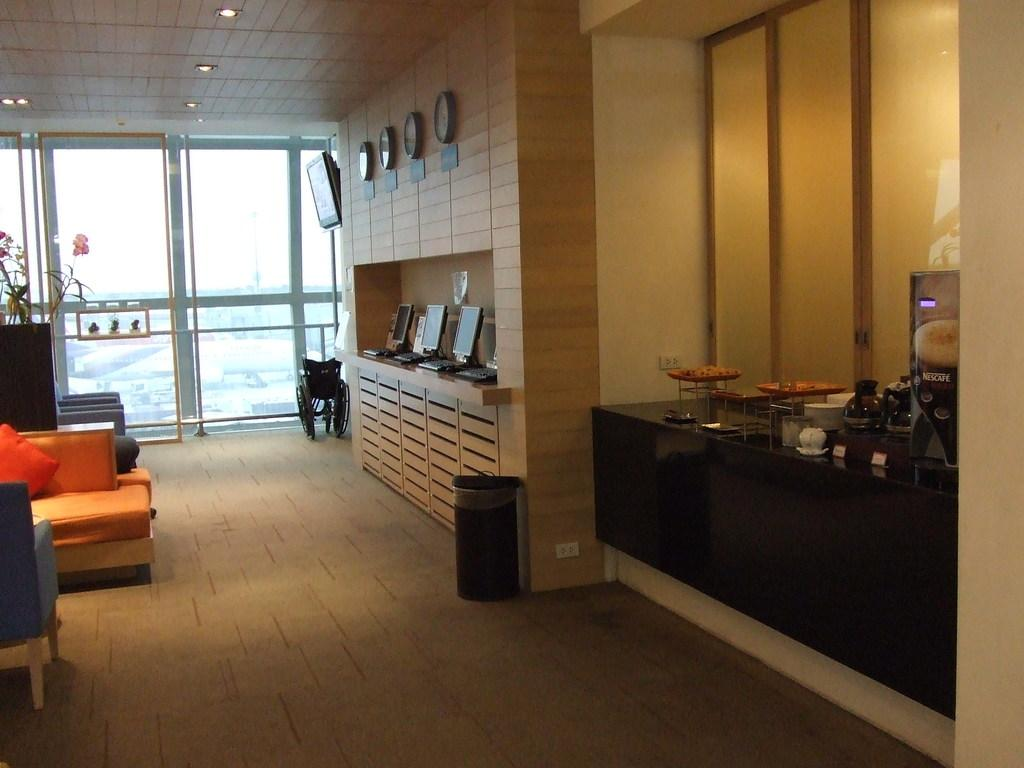What electronic device can be seen on the floor in the image? There is a laptop on the floor in the image. What time-telling device is also on the floor? There is a clock on the floor in the image. What mobility aid is visible on the floor? There is a wheelchair on the floor in the image. What type of container is on the floor? There is a bin on the floor in the image. What type of furniture is present in the image? There are chairs in the image. What type of soft furnishings are present in the image? There are pillows in the image. What can be seen in the background of the image? There is a window in the background of the image. What can be seen on the countertop in the image? There is a cup and a jar on the countertop in the image. What type of reward is being offered to the person sitting in the wheelchair in the image? There is no indication of a reward being offered in the image; it simply shows a laptop, clock, wheelchair, bin, chairs, pillows, a window, and a cup and jar on the countertop. How much salt is visible in the image? There is no salt present in the image. 